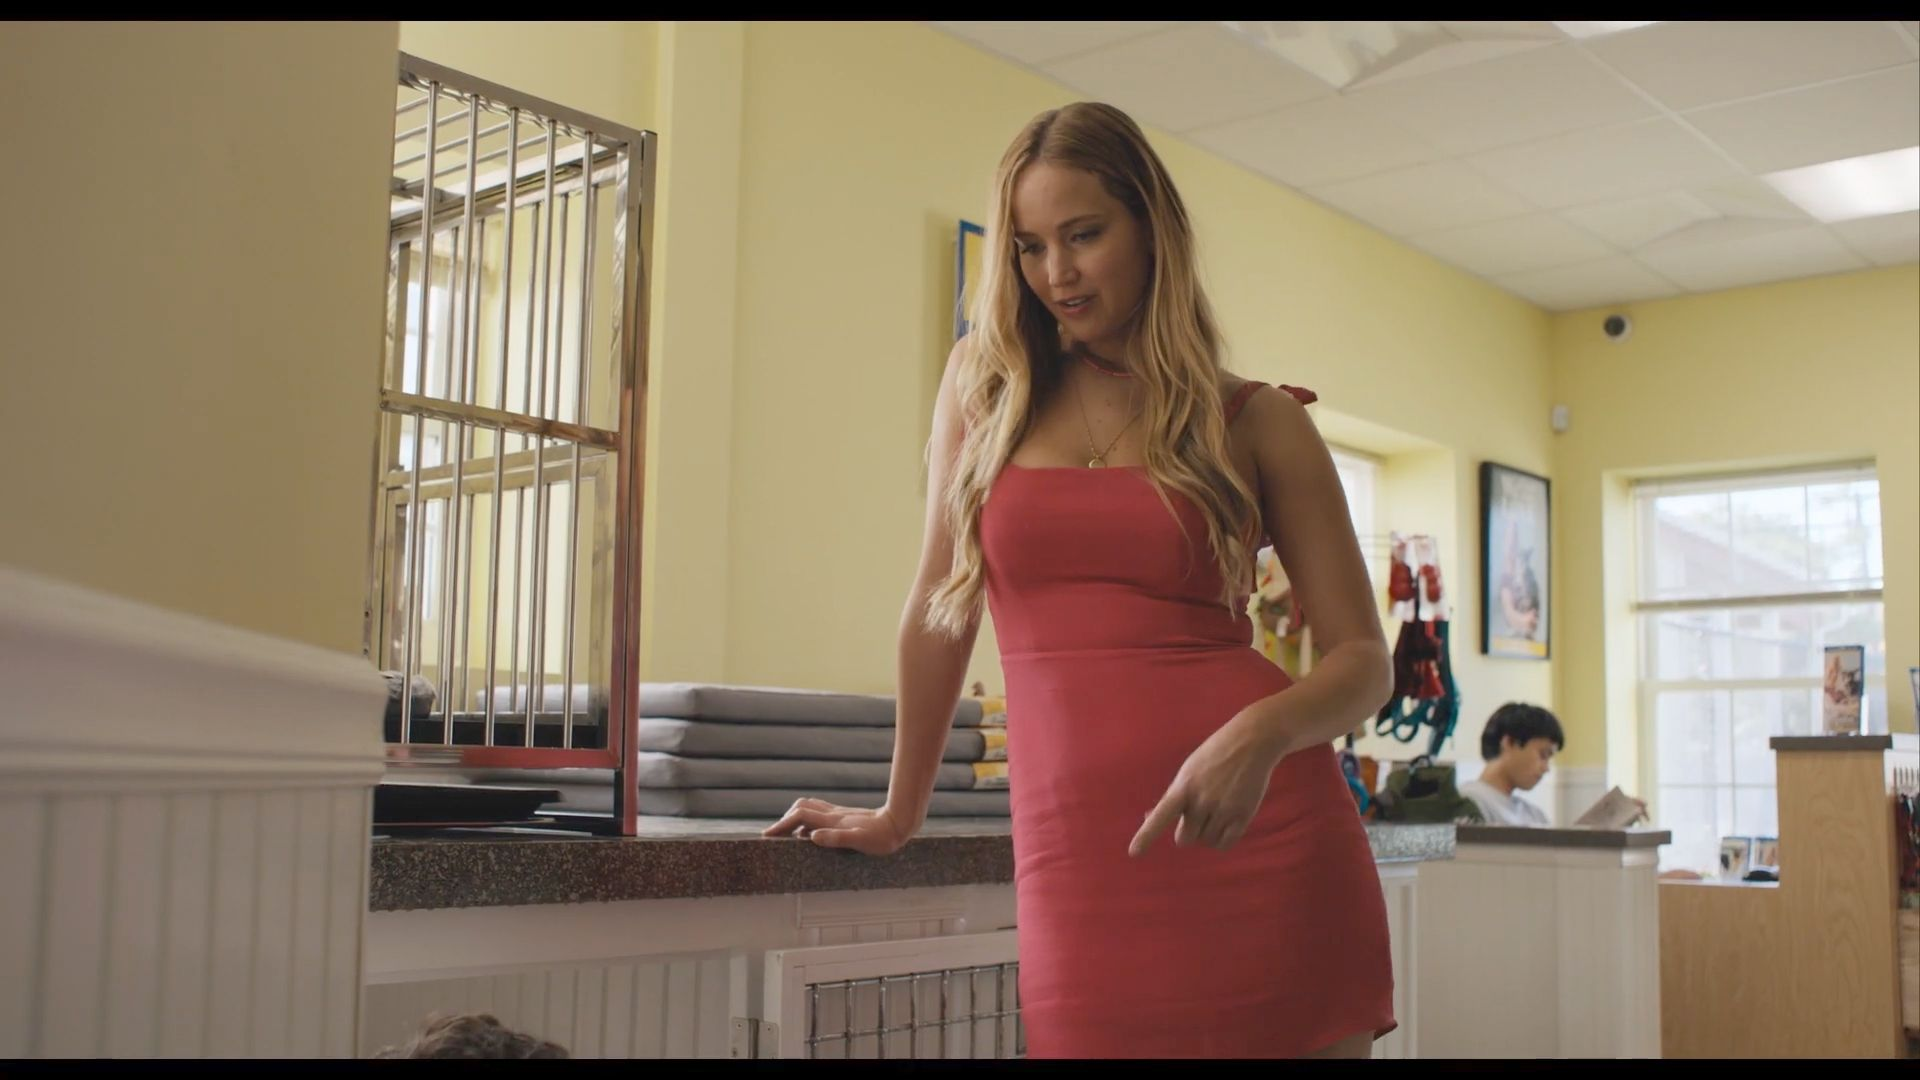Write a detailed description of the given image. The image shows a woman dressed in a form-fitting, red knee-length dress inside a brightly lit diner. Her stance is relaxed with one hand resting on the counter and the other placed on her hip as she looks down, likely at another person out of the frame. The diner features a yellow wall and a black and white checkered floor. Behind her, a barred window adds a distinctive architectural detail. The overall scene is vibrant and colorful, emphasizing the contrast between the woman's attire and the diner's interior. 